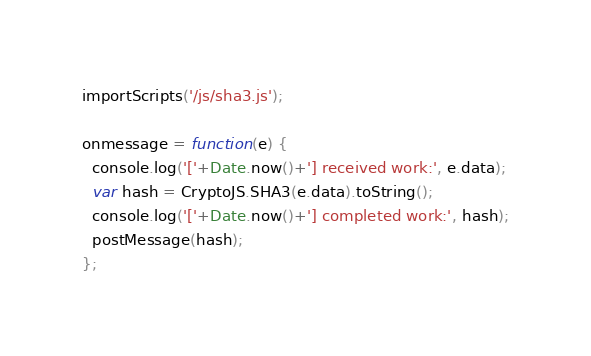Convert code to text. <code><loc_0><loc_0><loc_500><loc_500><_JavaScript_>importScripts('/js/sha3.js');

onmessage = function(e) {
  console.log('['+Date.now()+'] received work:', e.data);
  var hash = CryptoJS.SHA3(e.data).toString();
  console.log('['+Date.now()+'] completed work:', hash);
  postMessage(hash);
};
</code> 